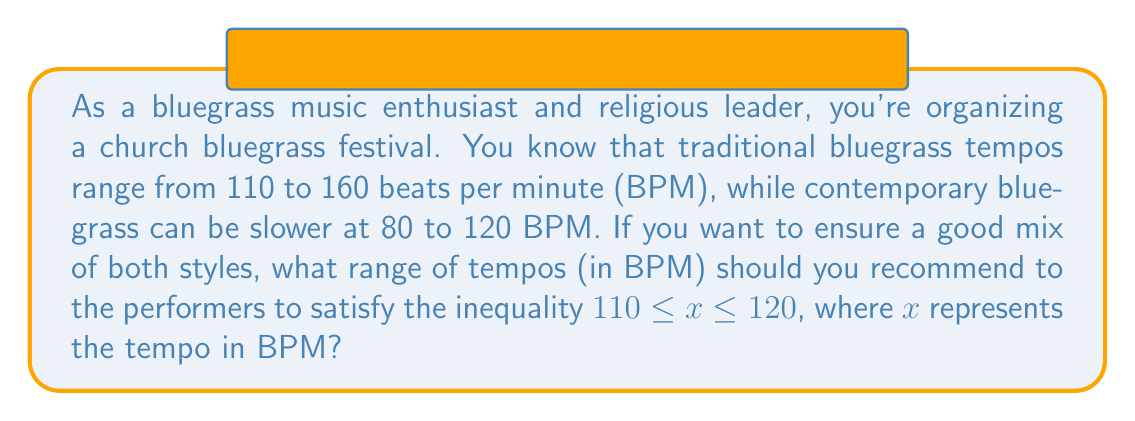Can you solve this math problem? To solve this problem, we need to consider the given inequality and the tempo ranges for both traditional and contemporary bluegrass:

1. Given inequality: $110 \leq x \leq 120$
2. Traditional bluegrass range: 110 to 160 BPM
3. Contemporary bluegrass range: 80 to 120 BPM

Step 1: Analyze the lower bound
The lower bound of our inequality (110 BPM) matches the lower bound of traditional bluegrass. This is acceptable for both styles.

Step 2: Analyze the upper bound
The upper bound of our inequality (120 BPM) is the upper bound of contemporary bluegrass and falls within the traditional bluegrass range. This is also acceptable for both styles.

Step 3: Determine the overlap
The range 110 to 120 BPM satisfies the given inequality and falls within both the traditional and contemporary bluegrass tempo ranges.

Therefore, the ideal tempo range that satisfies the inequality and accommodates both traditional and contemporary bluegrass styles is 110 to 120 BPM.
Answer: $[110, 120]$ BPM 